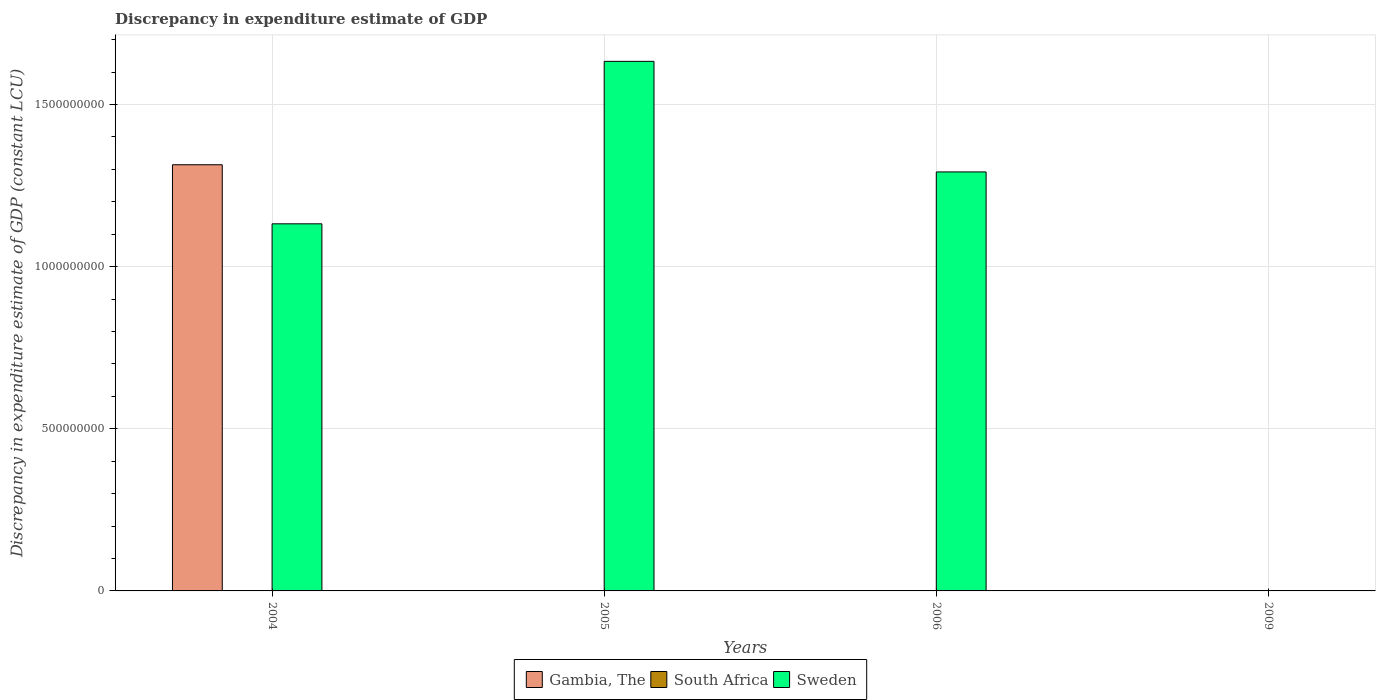Are the number of bars on each tick of the X-axis equal?
Offer a very short reply. No. How many bars are there on the 1st tick from the left?
Give a very brief answer. 2. How many bars are there on the 1st tick from the right?
Give a very brief answer. 0. In how many cases, is the number of bars for a given year not equal to the number of legend labels?
Offer a terse response. 4. Across all years, what is the maximum discrepancy in expenditure estimate of GDP in Gambia, The?
Ensure brevity in your answer.  1.31e+09. What is the difference between the discrepancy in expenditure estimate of GDP in Gambia, The in 2004 and that in 2005?
Make the answer very short. 1.31e+09. What is the difference between the discrepancy in expenditure estimate of GDP in South Africa in 2005 and the discrepancy in expenditure estimate of GDP in Gambia, The in 2004?
Keep it short and to the point. -1.31e+09. What is the average discrepancy in expenditure estimate of GDP in Sweden per year?
Offer a terse response. 1.01e+09. In the year 2004, what is the difference between the discrepancy in expenditure estimate of GDP in Sweden and discrepancy in expenditure estimate of GDP in Gambia, The?
Your answer should be compact. -1.82e+08. What is the ratio of the discrepancy in expenditure estimate of GDP in Gambia, The in 2004 to that in 2005?
Give a very brief answer. 1.31e+07. What is the difference between the highest and the second highest discrepancy in expenditure estimate of GDP in Sweden?
Your response must be concise. 3.41e+08. What is the difference between the highest and the lowest discrepancy in expenditure estimate of GDP in Sweden?
Your response must be concise. 1.63e+09. Is the sum of the discrepancy in expenditure estimate of GDP in Gambia, The in 2005 and 2006 greater than the maximum discrepancy in expenditure estimate of GDP in South Africa across all years?
Keep it short and to the point. Yes. Is it the case that in every year, the sum of the discrepancy in expenditure estimate of GDP in Gambia, The and discrepancy in expenditure estimate of GDP in South Africa is greater than the discrepancy in expenditure estimate of GDP in Sweden?
Offer a very short reply. No. How many bars are there?
Ensure brevity in your answer.  6. How many years are there in the graph?
Your response must be concise. 4. Does the graph contain any zero values?
Offer a terse response. Yes. Does the graph contain grids?
Ensure brevity in your answer.  Yes. How many legend labels are there?
Your response must be concise. 3. What is the title of the graph?
Keep it short and to the point. Discrepancy in expenditure estimate of GDP. What is the label or title of the X-axis?
Ensure brevity in your answer.  Years. What is the label or title of the Y-axis?
Make the answer very short. Discrepancy in expenditure estimate of GDP (constant LCU). What is the Discrepancy in expenditure estimate of GDP (constant LCU) in Gambia, The in 2004?
Give a very brief answer. 1.31e+09. What is the Discrepancy in expenditure estimate of GDP (constant LCU) in South Africa in 2004?
Provide a short and direct response. 0. What is the Discrepancy in expenditure estimate of GDP (constant LCU) of Sweden in 2004?
Provide a short and direct response. 1.13e+09. What is the Discrepancy in expenditure estimate of GDP (constant LCU) in Gambia, The in 2005?
Your answer should be compact. 100. What is the Discrepancy in expenditure estimate of GDP (constant LCU) in South Africa in 2005?
Your answer should be compact. 0. What is the Discrepancy in expenditure estimate of GDP (constant LCU) in Sweden in 2005?
Your answer should be very brief. 1.63e+09. What is the Discrepancy in expenditure estimate of GDP (constant LCU) of Gambia, The in 2006?
Offer a terse response. 100. What is the Discrepancy in expenditure estimate of GDP (constant LCU) in Sweden in 2006?
Keep it short and to the point. 1.29e+09. What is the Discrepancy in expenditure estimate of GDP (constant LCU) in South Africa in 2009?
Ensure brevity in your answer.  0. What is the Discrepancy in expenditure estimate of GDP (constant LCU) of Sweden in 2009?
Provide a short and direct response. 0. Across all years, what is the maximum Discrepancy in expenditure estimate of GDP (constant LCU) of Gambia, The?
Provide a succinct answer. 1.31e+09. Across all years, what is the maximum Discrepancy in expenditure estimate of GDP (constant LCU) in Sweden?
Give a very brief answer. 1.63e+09. What is the total Discrepancy in expenditure estimate of GDP (constant LCU) in Gambia, The in the graph?
Provide a short and direct response. 1.31e+09. What is the total Discrepancy in expenditure estimate of GDP (constant LCU) of Sweden in the graph?
Provide a succinct answer. 4.06e+09. What is the difference between the Discrepancy in expenditure estimate of GDP (constant LCU) in Gambia, The in 2004 and that in 2005?
Ensure brevity in your answer.  1.31e+09. What is the difference between the Discrepancy in expenditure estimate of GDP (constant LCU) in Sweden in 2004 and that in 2005?
Your answer should be compact. -5.01e+08. What is the difference between the Discrepancy in expenditure estimate of GDP (constant LCU) of Gambia, The in 2004 and that in 2006?
Provide a succinct answer. 1.31e+09. What is the difference between the Discrepancy in expenditure estimate of GDP (constant LCU) of Sweden in 2004 and that in 2006?
Keep it short and to the point. -1.60e+08. What is the difference between the Discrepancy in expenditure estimate of GDP (constant LCU) in Sweden in 2005 and that in 2006?
Give a very brief answer. 3.41e+08. What is the difference between the Discrepancy in expenditure estimate of GDP (constant LCU) of Gambia, The in 2004 and the Discrepancy in expenditure estimate of GDP (constant LCU) of Sweden in 2005?
Make the answer very short. -3.19e+08. What is the difference between the Discrepancy in expenditure estimate of GDP (constant LCU) of Gambia, The in 2004 and the Discrepancy in expenditure estimate of GDP (constant LCU) of Sweden in 2006?
Keep it short and to the point. 2.22e+07. What is the difference between the Discrepancy in expenditure estimate of GDP (constant LCU) of Gambia, The in 2005 and the Discrepancy in expenditure estimate of GDP (constant LCU) of Sweden in 2006?
Offer a very short reply. -1.29e+09. What is the average Discrepancy in expenditure estimate of GDP (constant LCU) in Gambia, The per year?
Give a very brief answer. 3.29e+08. What is the average Discrepancy in expenditure estimate of GDP (constant LCU) of Sweden per year?
Offer a terse response. 1.01e+09. In the year 2004, what is the difference between the Discrepancy in expenditure estimate of GDP (constant LCU) in Gambia, The and Discrepancy in expenditure estimate of GDP (constant LCU) in Sweden?
Keep it short and to the point. 1.82e+08. In the year 2005, what is the difference between the Discrepancy in expenditure estimate of GDP (constant LCU) in Gambia, The and Discrepancy in expenditure estimate of GDP (constant LCU) in Sweden?
Provide a succinct answer. -1.63e+09. In the year 2006, what is the difference between the Discrepancy in expenditure estimate of GDP (constant LCU) in Gambia, The and Discrepancy in expenditure estimate of GDP (constant LCU) in Sweden?
Keep it short and to the point. -1.29e+09. What is the ratio of the Discrepancy in expenditure estimate of GDP (constant LCU) of Gambia, The in 2004 to that in 2005?
Your response must be concise. 1.31e+07. What is the ratio of the Discrepancy in expenditure estimate of GDP (constant LCU) of Sweden in 2004 to that in 2005?
Ensure brevity in your answer.  0.69. What is the ratio of the Discrepancy in expenditure estimate of GDP (constant LCU) in Gambia, The in 2004 to that in 2006?
Provide a succinct answer. 1.31e+07. What is the ratio of the Discrepancy in expenditure estimate of GDP (constant LCU) in Sweden in 2004 to that in 2006?
Your answer should be compact. 0.88. What is the ratio of the Discrepancy in expenditure estimate of GDP (constant LCU) in Gambia, The in 2005 to that in 2006?
Your answer should be compact. 1. What is the ratio of the Discrepancy in expenditure estimate of GDP (constant LCU) in Sweden in 2005 to that in 2006?
Keep it short and to the point. 1.26. What is the difference between the highest and the second highest Discrepancy in expenditure estimate of GDP (constant LCU) in Gambia, The?
Offer a very short reply. 1.31e+09. What is the difference between the highest and the second highest Discrepancy in expenditure estimate of GDP (constant LCU) in Sweden?
Your response must be concise. 3.41e+08. What is the difference between the highest and the lowest Discrepancy in expenditure estimate of GDP (constant LCU) in Gambia, The?
Your response must be concise. 1.31e+09. What is the difference between the highest and the lowest Discrepancy in expenditure estimate of GDP (constant LCU) of Sweden?
Keep it short and to the point. 1.63e+09. 